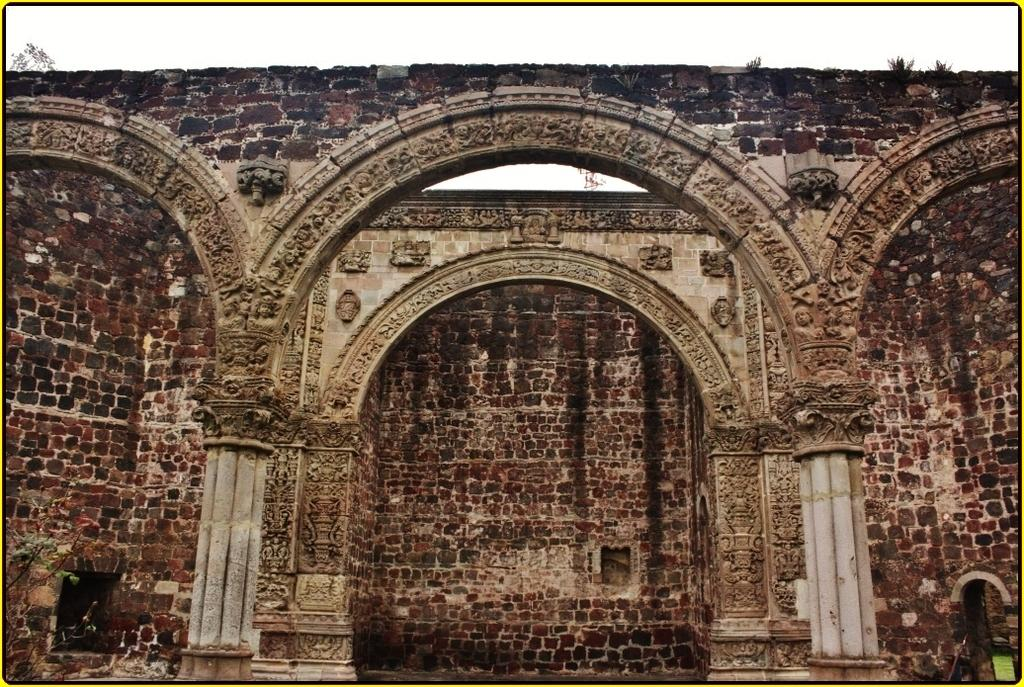What type of structure is present in the image? There is an arch in the image. What type of school is depicted in the image? There is no school present in the image; it only features an arch. What game is being played under the arch in the image? There is no game being played in the image; it only features an arch. 